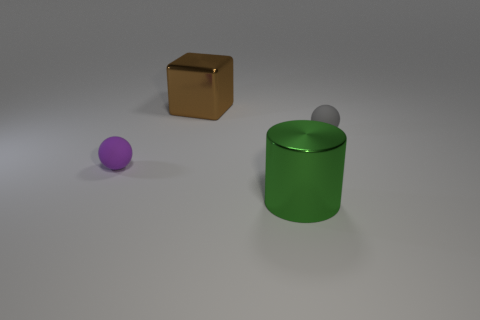There is a purple sphere; are there any purple matte spheres to the left of it?
Offer a very short reply. No. What number of objects are tiny spheres to the left of the large green thing or brown objects?
Your answer should be compact. 2. There is a cylinder that is made of the same material as the big brown cube; what is its size?
Ensure brevity in your answer.  Large. There is a green shiny cylinder; is it the same size as the metallic object behind the green metal cylinder?
Your answer should be compact. Yes. What color is the object that is in front of the gray rubber thing and behind the large green cylinder?
Your answer should be very brief. Purple. What number of things are objects that are to the right of the green thing or big objects on the right side of the big brown thing?
Your answer should be compact. 2. What color is the tiny ball that is on the right side of the large metal object that is behind the matte ball to the right of the small purple sphere?
Ensure brevity in your answer.  Gray. Are there any other objects that have the same shape as the large brown shiny thing?
Make the answer very short. No. What number of green cylinders are there?
Your response must be concise. 1. There is a green shiny thing; what shape is it?
Your response must be concise. Cylinder. 